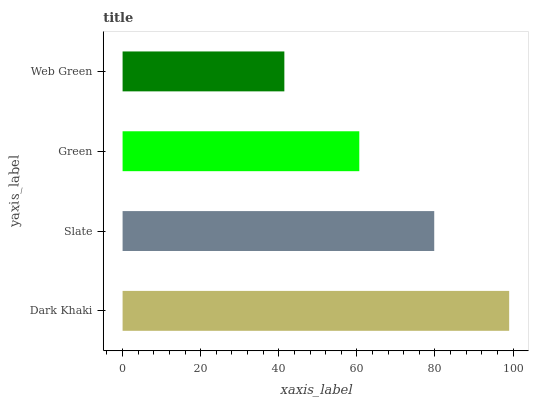Is Web Green the minimum?
Answer yes or no. Yes. Is Dark Khaki the maximum?
Answer yes or no. Yes. Is Slate the minimum?
Answer yes or no. No. Is Slate the maximum?
Answer yes or no. No. Is Dark Khaki greater than Slate?
Answer yes or no. Yes. Is Slate less than Dark Khaki?
Answer yes or no. Yes. Is Slate greater than Dark Khaki?
Answer yes or no. No. Is Dark Khaki less than Slate?
Answer yes or no. No. Is Slate the high median?
Answer yes or no. Yes. Is Green the low median?
Answer yes or no. Yes. Is Web Green the high median?
Answer yes or no. No. Is Slate the low median?
Answer yes or no. No. 